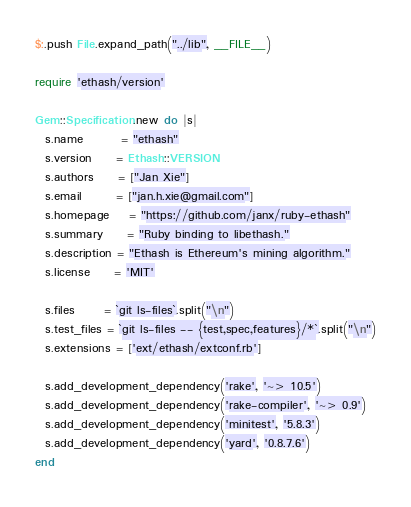<code> <loc_0><loc_0><loc_500><loc_500><_Ruby_>$:.push File.expand_path("../lib", __FILE__)

require 'ethash/version'

Gem::Specification.new do |s|
  s.name        = "ethash"
  s.version     = Ethash::VERSION
  s.authors     = ["Jan Xie"]
  s.email       = ["jan.h.xie@gmail.com"]
  s.homepage    = "https://github.com/janx/ruby-ethash"
  s.summary     = "Ruby binding to libethash."
  s.description = "Ethash is Ethereum's mining algorithm."
  s.license     = 'MIT'

  s.files      = `git ls-files`.split("\n")
  s.test_files = `git ls-files -- {test,spec,features}/*`.split("\n")
  s.extensions = ['ext/ethash/extconf.rb']

  s.add_development_dependency('rake', '~> 10.5')
  s.add_development_dependency('rake-compiler', '~> 0.9')
  s.add_development_dependency('minitest', '5.8.3')
  s.add_development_dependency('yard', '0.8.7.6')
end
</code> 